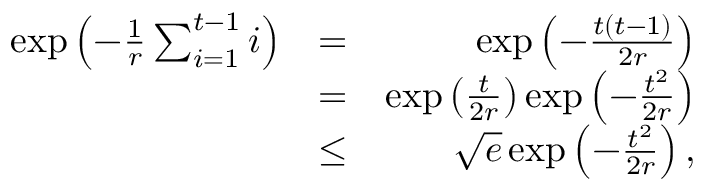Convert formula to latex. <formula><loc_0><loc_0><loc_500><loc_500>\begin{array} { r l r } { \exp \left ( - \frac { 1 } { r } \sum _ { i = 1 } ^ { t - 1 } i \right ) } & { = } & { \exp \left ( - \frac { t ( t - 1 ) } { 2 r } \right ) } \\ & { = } & { \exp \left ( \frac { t } { 2 r } \right ) \exp \left ( - \frac { t ^ { 2 } } { 2 r } \right ) } \\ & { \leq } & { \sqrt { e } \exp \left ( - \frac { t ^ { 2 } } { 2 r } \right ) , } \end{array}</formula> 